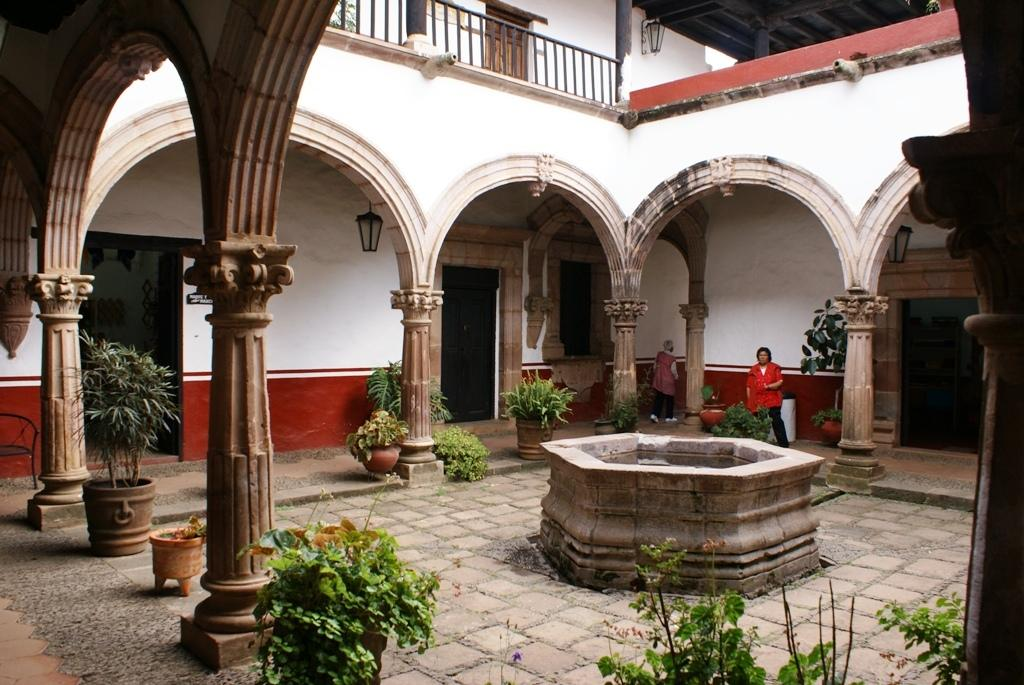Where was the image taken? The image was taken inside a building. What can be seen in the image related to plants? There are flower pots and plants in the image. What type of lighting is present in the image? There are lights in the image. How many people are visible in the image? Two persons are standing on the ground in the image. What type of doctor is standing next to the bridge in the image? There is no doctor or bridge present in the image. 